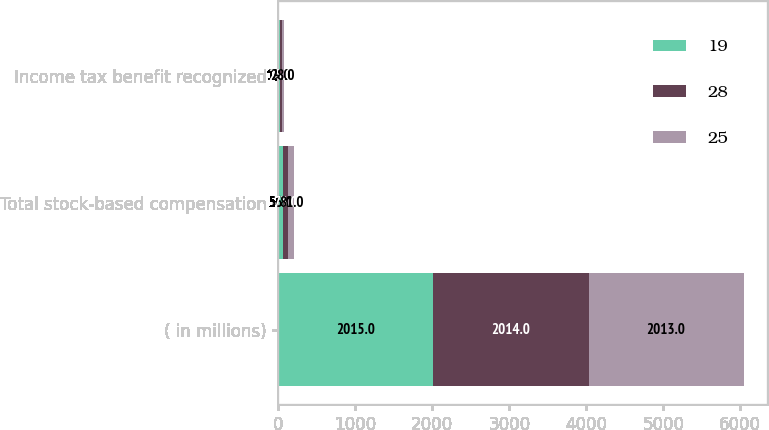Convert chart to OTSL. <chart><loc_0><loc_0><loc_500><loc_500><stacked_bar_chart><ecel><fcel>( in millions)<fcel>Total stock-based compensation<fcel>Income tax benefit recognized<nl><fcel>19<fcel>2015<fcel>56<fcel>19<nl><fcel>28<fcel>2014<fcel>73<fcel>25<nl><fcel>25<fcel>2013<fcel>81<fcel>28<nl></chart> 